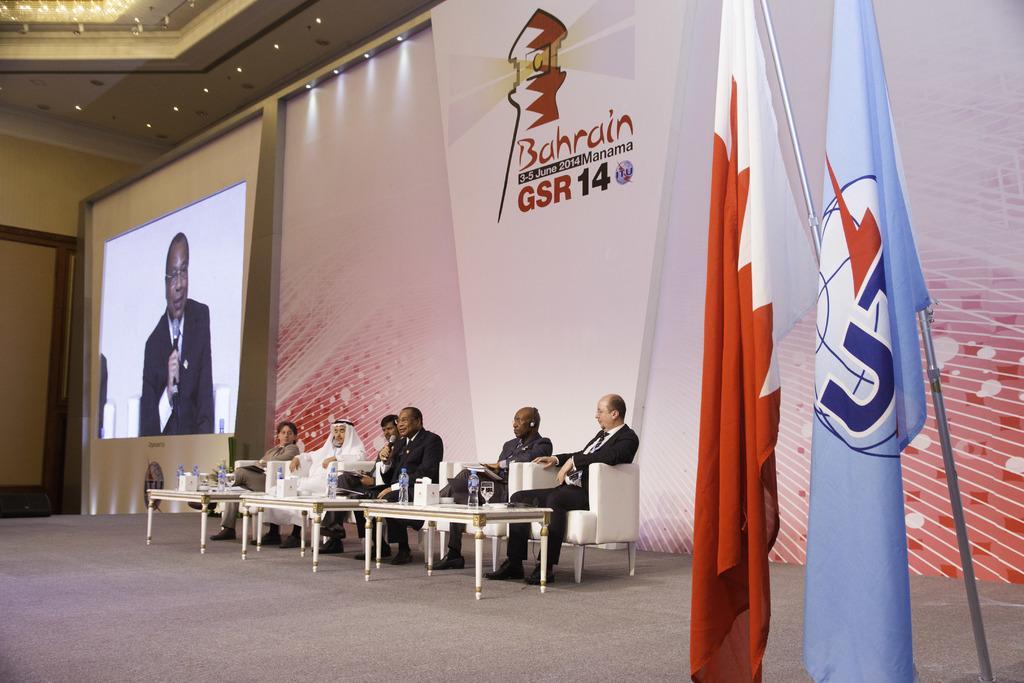How would you summarize this image in a sentence or two? There are many people sitting on chairs. In front of them there are many tables. On the table there are many bottles, glasses and many other items. On the right side there are two flags. In the background there is a wall with a logo. On the left side there is a screen, On the ceiling there are lights. 